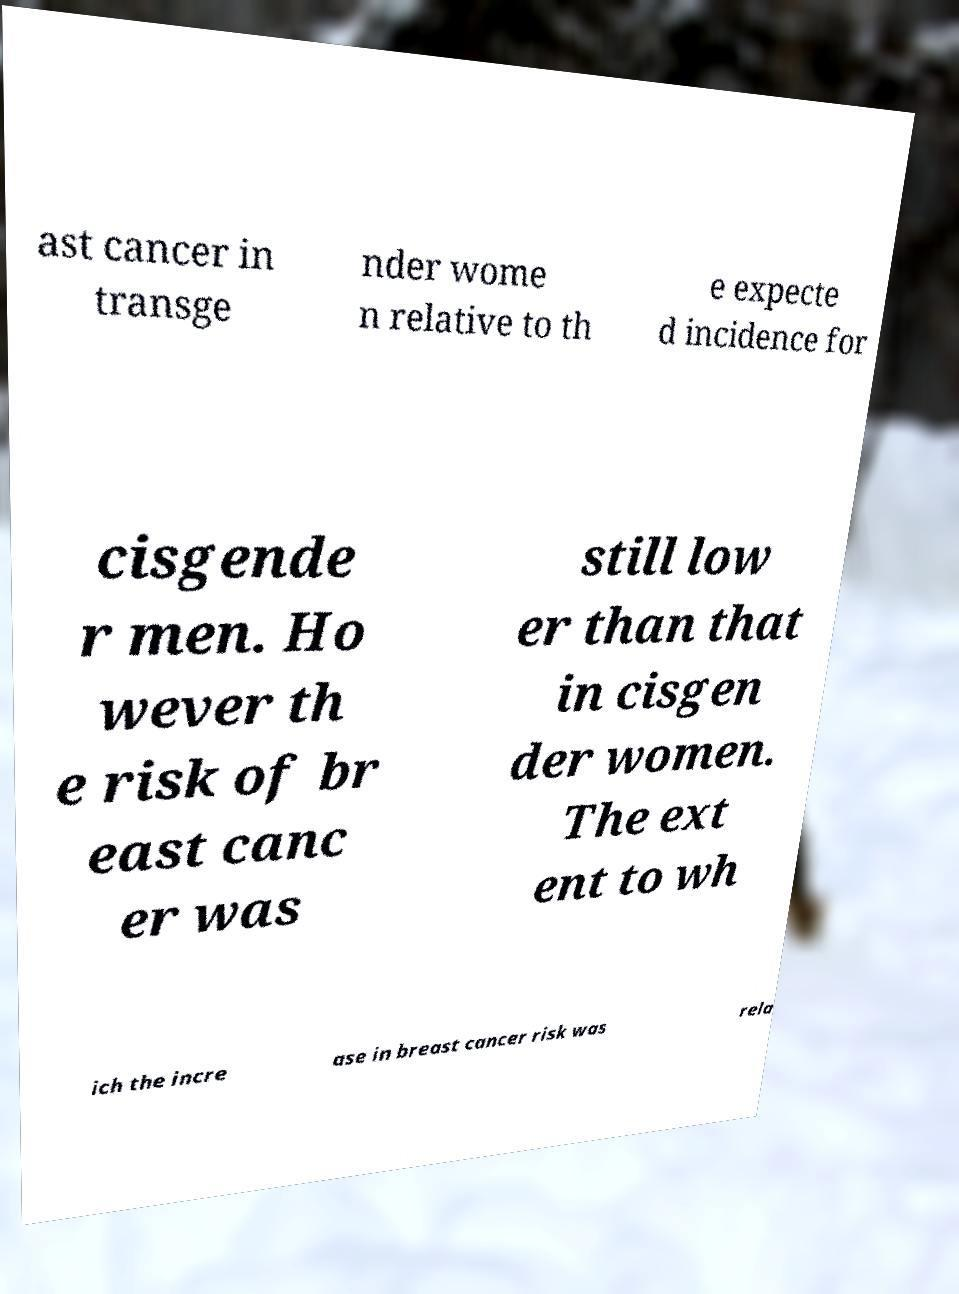Could you extract and type out the text from this image? ast cancer in transge nder wome n relative to th e expecte d incidence for cisgende r men. Ho wever th e risk of br east canc er was still low er than that in cisgen der women. The ext ent to wh ich the incre ase in breast cancer risk was rela 